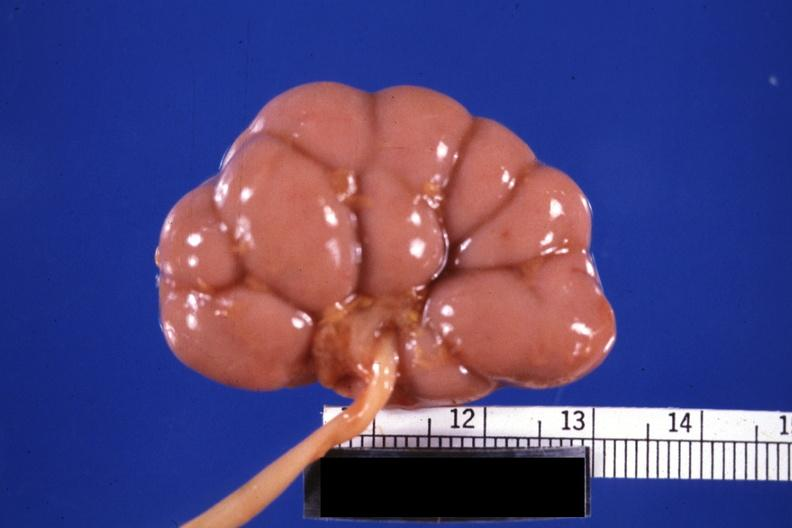where is this?
Answer the question using a single word or phrase. Urinary 